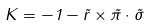<formula> <loc_0><loc_0><loc_500><loc_500>K = - 1 - \vec { r } \times \vec { \pi } \cdot \vec { \sigma }</formula> 